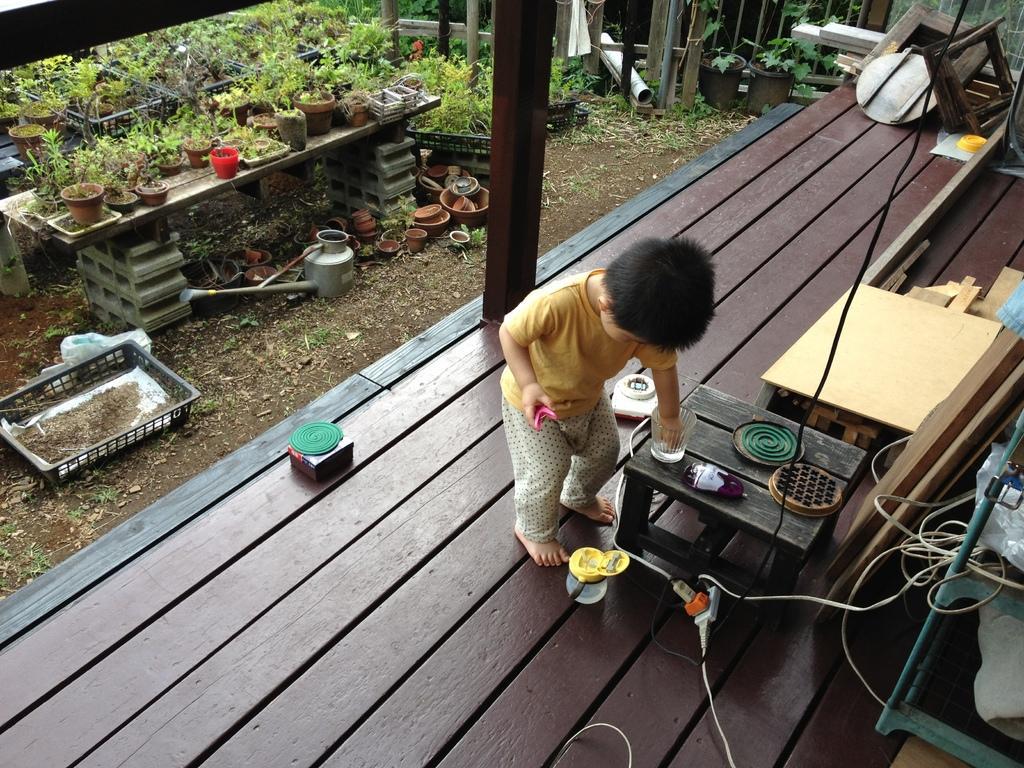Please provide a concise description of this image. At the bottom of the image on the wooden surface there is a boy standing. In front of him there is a table with glass and some other things on it. On the right corner of the image there is a stand with covers. And also there are wires, wooden objects and some other things. Behind the wooden surface on the ground there are dry leaves, pots and a basket. There is a table with potted plants. And also there are few potted plants on the ground. Behind them there is a wooden fencing. 